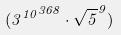<formula> <loc_0><loc_0><loc_500><loc_500>( { 3 ^ { 1 0 } } ^ { 3 6 8 } \cdot \sqrt { 5 } ^ { 9 } )</formula> 